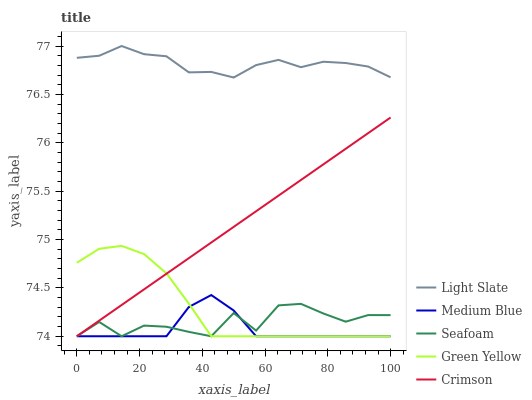Does Medium Blue have the minimum area under the curve?
Answer yes or no. Yes. Does Light Slate have the maximum area under the curve?
Answer yes or no. Yes. Does Crimson have the minimum area under the curve?
Answer yes or no. No. Does Crimson have the maximum area under the curve?
Answer yes or no. No. Is Crimson the smoothest?
Answer yes or no. Yes. Is Seafoam the roughest?
Answer yes or no. Yes. Is Green Yellow the smoothest?
Answer yes or no. No. Is Green Yellow the roughest?
Answer yes or no. No. Does Crimson have the lowest value?
Answer yes or no. Yes. Does Light Slate have the highest value?
Answer yes or no. Yes. Does Crimson have the highest value?
Answer yes or no. No. Is Crimson less than Light Slate?
Answer yes or no. Yes. Is Light Slate greater than Seafoam?
Answer yes or no. Yes. Does Green Yellow intersect Seafoam?
Answer yes or no. Yes. Is Green Yellow less than Seafoam?
Answer yes or no. No. Is Green Yellow greater than Seafoam?
Answer yes or no. No. Does Crimson intersect Light Slate?
Answer yes or no. No. 